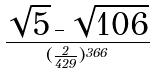Convert formula to latex. <formula><loc_0><loc_0><loc_500><loc_500>\frac { \sqrt { 5 } - \sqrt { 1 0 6 } } { ( \frac { 2 } { 4 2 9 } ) ^ { 3 6 6 } }</formula> 